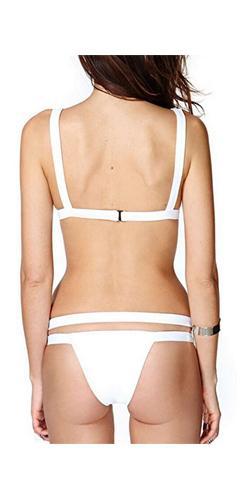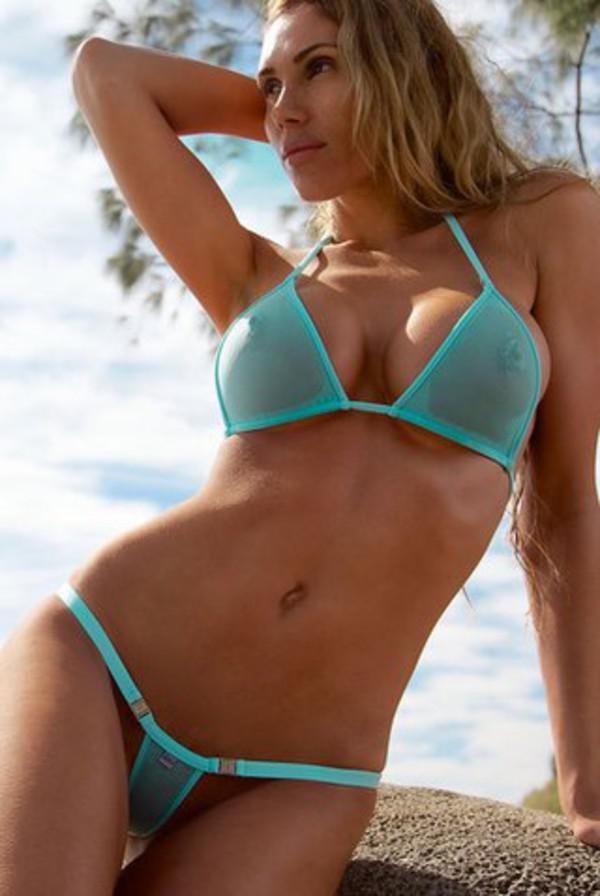The first image is the image on the left, the second image is the image on the right. For the images shown, is this caption "In one of the images, a woman is wearing a white bikini" true? Answer yes or no. Yes. The first image is the image on the left, the second image is the image on the right. Analyze the images presented: Is the assertion "Models wear the same color bikinis in left and right images." valid? Answer yes or no. No. 